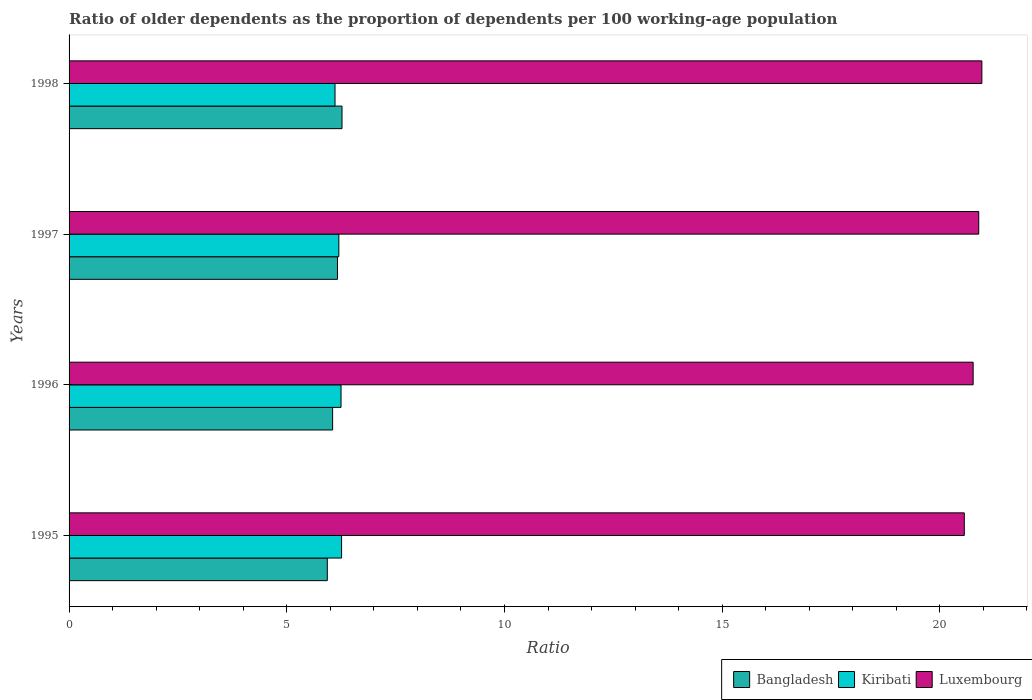Are the number of bars on each tick of the Y-axis equal?
Give a very brief answer. Yes. How many bars are there on the 4th tick from the top?
Provide a succinct answer. 3. How many bars are there on the 4th tick from the bottom?
Give a very brief answer. 3. What is the label of the 3rd group of bars from the top?
Your response must be concise. 1996. In how many cases, is the number of bars for a given year not equal to the number of legend labels?
Give a very brief answer. 0. What is the age dependency ratio(old) in Kiribati in 1996?
Provide a short and direct response. 6.25. Across all years, what is the maximum age dependency ratio(old) in Luxembourg?
Provide a succinct answer. 20.96. Across all years, what is the minimum age dependency ratio(old) in Luxembourg?
Your answer should be compact. 20.56. In which year was the age dependency ratio(old) in Luxembourg maximum?
Give a very brief answer. 1998. What is the total age dependency ratio(old) in Kiribati in the graph?
Provide a succinct answer. 24.81. What is the difference between the age dependency ratio(old) in Bangladesh in 1995 and that in 1997?
Keep it short and to the point. -0.23. What is the difference between the age dependency ratio(old) in Luxembourg in 1995 and the age dependency ratio(old) in Kiribati in 1997?
Provide a short and direct response. 14.36. What is the average age dependency ratio(old) in Kiribati per year?
Provide a short and direct response. 6.2. In the year 1998, what is the difference between the age dependency ratio(old) in Luxembourg and age dependency ratio(old) in Kiribati?
Provide a short and direct response. 14.86. In how many years, is the age dependency ratio(old) in Luxembourg greater than 13 ?
Offer a very short reply. 4. What is the ratio of the age dependency ratio(old) in Kiribati in 1995 to that in 1998?
Make the answer very short. 1.02. Is the age dependency ratio(old) in Bangladesh in 1996 less than that in 1998?
Your response must be concise. Yes. Is the difference between the age dependency ratio(old) in Luxembourg in 1995 and 1997 greater than the difference between the age dependency ratio(old) in Kiribati in 1995 and 1997?
Provide a succinct answer. No. What is the difference between the highest and the second highest age dependency ratio(old) in Kiribati?
Keep it short and to the point. 0.01. What is the difference between the highest and the lowest age dependency ratio(old) in Luxembourg?
Give a very brief answer. 0.4. In how many years, is the age dependency ratio(old) in Luxembourg greater than the average age dependency ratio(old) in Luxembourg taken over all years?
Your response must be concise. 2. Is the sum of the age dependency ratio(old) in Luxembourg in 1995 and 1997 greater than the maximum age dependency ratio(old) in Kiribati across all years?
Ensure brevity in your answer.  Yes. What does the 2nd bar from the top in 1997 represents?
Make the answer very short. Kiribati. What does the 2nd bar from the bottom in 1998 represents?
Offer a terse response. Kiribati. How many bars are there?
Make the answer very short. 12. Are all the bars in the graph horizontal?
Give a very brief answer. Yes. How many years are there in the graph?
Your answer should be compact. 4. Are the values on the major ticks of X-axis written in scientific E-notation?
Give a very brief answer. No. Where does the legend appear in the graph?
Keep it short and to the point. Bottom right. How are the legend labels stacked?
Keep it short and to the point. Horizontal. What is the title of the graph?
Give a very brief answer. Ratio of older dependents as the proportion of dependents per 100 working-age population. Does "Haiti" appear as one of the legend labels in the graph?
Provide a succinct answer. No. What is the label or title of the X-axis?
Give a very brief answer. Ratio. What is the Ratio in Bangladesh in 1995?
Keep it short and to the point. 5.93. What is the Ratio in Kiribati in 1995?
Ensure brevity in your answer.  6.26. What is the Ratio of Luxembourg in 1995?
Provide a succinct answer. 20.56. What is the Ratio of Bangladesh in 1996?
Provide a succinct answer. 6.05. What is the Ratio of Kiribati in 1996?
Make the answer very short. 6.25. What is the Ratio in Luxembourg in 1996?
Provide a short and direct response. 20.76. What is the Ratio of Bangladesh in 1997?
Your answer should be compact. 6.16. What is the Ratio of Kiribati in 1997?
Your answer should be very brief. 6.2. What is the Ratio of Luxembourg in 1997?
Provide a short and direct response. 20.89. What is the Ratio of Bangladesh in 1998?
Your answer should be compact. 6.27. What is the Ratio of Kiribati in 1998?
Your response must be concise. 6.11. What is the Ratio in Luxembourg in 1998?
Give a very brief answer. 20.96. Across all years, what is the maximum Ratio of Bangladesh?
Provide a succinct answer. 6.27. Across all years, what is the maximum Ratio in Kiribati?
Your answer should be compact. 6.26. Across all years, what is the maximum Ratio of Luxembourg?
Ensure brevity in your answer.  20.96. Across all years, what is the minimum Ratio of Bangladesh?
Give a very brief answer. 5.93. Across all years, what is the minimum Ratio in Kiribati?
Provide a succinct answer. 6.11. Across all years, what is the minimum Ratio of Luxembourg?
Keep it short and to the point. 20.56. What is the total Ratio in Bangladesh in the graph?
Your answer should be very brief. 24.42. What is the total Ratio in Kiribati in the graph?
Provide a succinct answer. 24.81. What is the total Ratio in Luxembourg in the graph?
Your answer should be very brief. 83.18. What is the difference between the Ratio in Bangladesh in 1995 and that in 1996?
Provide a short and direct response. -0.12. What is the difference between the Ratio in Kiribati in 1995 and that in 1996?
Provide a short and direct response. 0.01. What is the difference between the Ratio of Luxembourg in 1995 and that in 1996?
Make the answer very short. -0.2. What is the difference between the Ratio in Bangladesh in 1995 and that in 1997?
Provide a succinct answer. -0.23. What is the difference between the Ratio of Kiribati in 1995 and that in 1997?
Provide a short and direct response. 0.06. What is the difference between the Ratio in Luxembourg in 1995 and that in 1997?
Offer a very short reply. -0.33. What is the difference between the Ratio in Bangladesh in 1995 and that in 1998?
Your response must be concise. -0.34. What is the difference between the Ratio in Kiribati in 1995 and that in 1998?
Give a very brief answer. 0.15. What is the difference between the Ratio in Luxembourg in 1995 and that in 1998?
Give a very brief answer. -0.4. What is the difference between the Ratio in Bangladesh in 1996 and that in 1997?
Provide a short and direct response. -0.11. What is the difference between the Ratio in Kiribati in 1996 and that in 1997?
Ensure brevity in your answer.  0.05. What is the difference between the Ratio of Luxembourg in 1996 and that in 1997?
Your answer should be very brief. -0.13. What is the difference between the Ratio in Bangladesh in 1996 and that in 1998?
Ensure brevity in your answer.  -0.22. What is the difference between the Ratio of Kiribati in 1996 and that in 1998?
Offer a terse response. 0.14. What is the difference between the Ratio in Bangladesh in 1997 and that in 1998?
Offer a terse response. -0.1. What is the difference between the Ratio in Kiribati in 1997 and that in 1998?
Offer a terse response. 0.09. What is the difference between the Ratio in Luxembourg in 1997 and that in 1998?
Provide a short and direct response. -0.07. What is the difference between the Ratio of Bangladesh in 1995 and the Ratio of Kiribati in 1996?
Offer a terse response. -0.32. What is the difference between the Ratio of Bangladesh in 1995 and the Ratio of Luxembourg in 1996?
Make the answer very short. -14.83. What is the difference between the Ratio in Kiribati in 1995 and the Ratio in Luxembourg in 1996?
Offer a very short reply. -14.51. What is the difference between the Ratio in Bangladesh in 1995 and the Ratio in Kiribati in 1997?
Your answer should be compact. -0.27. What is the difference between the Ratio of Bangladesh in 1995 and the Ratio of Luxembourg in 1997?
Your response must be concise. -14.96. What is the difference between the Ratio of Kiribati in 1995 and the Ratio of Luxembourg in 1997?
Your answer should be compact. -14.63. What is the difference between the Ratio in Bangladesh in 1995 and the Ratio in Kiribati in 1998?
Your answer should be compact. -0.18. What is the difference between the Ratio in Bangladesh in 1995 and the Ratio in Luxembourg in 1998?
Ensure brevity in your answer.  -15.03. What is the difference between the Ratio in Kiribati in 1995 and the Ratio in Luxembourg in 1998?
Your answer should be compact. -14.71. What is the difference between the Ratio of Bangladesh in 1996 and the Ratio of Kiribati in 1997?
Your response must be concise. -0.14. What is the difference between the Ratio in Bangladesh in 1996 and the Ratio in Luxembourg in 1997?
Your response must be concise. -14.84. What is the difference between the Ratio of Kiribati in 1996 and the Ratio of Luxembourg in 1997?
Make the answer very short. -14.65. What is the difference between the Ratio in Bangladesh in 1996 and the Ratio in Kiribati in 1998?
Offer a terse response. -0.05. What is the difference between the Ratio of Bangladesh in 1996 and the Ratio of Luxembourg in 1998?
Your response must be concise. -14.91. What is the difference between the Ratio in Kiribati in 1996 and the Ratio in Luxembourg in 1998?
Provide a succinct answer. -14.72. What is the difference between the Ratio in Bangladesh in 1997 and the Ratio in Kiribati in 1998?
Provide a short and direct response. 0.06. What is the difference between the Ratio in Bangladesh in 1997 and the Ratio in Luxembourg in 1998?
Offer a terse response. -14.8. What is the difference between the Ratio of Kiribati in 1997 and the Ratio of Luxembourg in 1998?
Your answer should be compact. -14.77. What is the average Ratio of Bangladesh per year?
Give a very brief answer. 6.1. What is the average Ratio in Kiribati per year?
Your answer should be compact. 6.2. What is the average Ratio in Luxembourg per year?
Make the answer very short. 20.8. In the year 1995, what is the difference between the Ratio of Bangladesh and Ratio of Kiribati?
Keep it short and to the point. -0.33. In the year 1995, what is the difference between the Ratio in Bangladesh and Ratio in Luxembourg?
Make the answer very short. -14.63. In the year 1995, what is the difference between the Ratio in Kiribati and Ratio in Luxembourg?
Ensure brevity in your answer.  -14.3. In the year 1996, what is the difference between the Ratio of Bangladesh and Ratio of Kiribati?
Your answer should be very brief. -0.19. In the year 1996, what is the difference between the Ratio in Bangladesh and Ratio in Luxembourg?
Provide a succinct answer. -14.71. In the year 1996, what is the difference between the Ratio in Kiribati and Ratio in Luxembourg?
Your response must be concise. -14.52. In the year 1997, what is the difference between the Ratio in Bangladesh and Ratio in Kiribati?
Offer a very short reply. -0.03. In the year 1997, what is the difference between the Ratio of Bangladesh and Ratio of Luxembourg?
Give a very brief answer. -14.73. In the year 1997, what is the difference between the Ratio in Kiribati and Ratio in Luxembourg?
Ensure brevity in your answer.  -14.7. In the year 1998, what is the difference between the Ratio in Bangladesh and Ratio in Kiribati?
Your answer should be very brief. 0.16. In the year 1998, what is the difference between the Ratio of Bangladesh and Ratio of Luxembourg?
Make the answer very short. -14.7. In the year 1998, what is the difference between the Ratio in Kiribati and Ratio in Luxembourg?
Your response must be concise. -14.86. What is the ratio of the Ratio in Bangladesh in 1995 to that in 1996?
Your answer should be very brief. 0.98. What is the ratio of the Ratio in Luxembourg in 1995 to that in 1996?
Make the answer very short. 0.99. What is the ratio of the Ratio of Bangladesh in 1995 to that in 1997?
Your answer should be compact. 0.96. What is the ratio of the Ratio in Kiribati in 1995 to that in 1997?
Give a very brief answer. 1.01. What is the ratio of the Ratio in Luxembourg in 1995 to that in 1997?
Make the answer very short. 0.98. What is the ratio of the Ratio in Bangladesh in 1995 to that in 1998?
Your answer should be very brief. 0.95. What is the ratio of the Ratio in Kiribati in 1995 to that in 1998?
Your response must be concise. 1.02. What is the ratio of the Ratio in Luxembourg in 1995 to that in 1998?
Offer a very short reply. 0.98. What is the ratio of the Ratio in Bangladesh in 1996 to that in 1997?
Your response must be concise. 0.98. What is the ratio of the Ratio in Kiribati in 1996 to that in 1997?
Offer a very short reply. 1.01. What is the ratio of the Ratio in Bangladesh in 1996 to that in 1998?
Give a very brief answer. 0.97. What is the ratio of the Ratio of Kiribati in 1996 to that in 1998?
Your answer should be very brief. 1.02. What is the ratio of the Ratio in Bangladesh in 1997 to that in 1998?
Ensure brevity in your answer.  0.98. What is the ratio of the Ratio in Kiribati in 1997 to that in 1998?
Provide a succinct answer. 1.01. What is the difference between the highest and the second highest Ratio of Bangladesh?
Your answer should be compact. 0.1. What is the difference between the highest and the second highest Ratio of Kiribati?
Give a very brief answer. 0.01. What is the difference between the highest and the second highest Ratio of Luxembourg?
Offer a terse response. 0.07. What is the difference between the highest and the lowest Ratio of Bangladesh?
Keep it short and to the point. 0.34. What is the difference between the highest and the lowest Ratio in Kiribati?
Give a very brief answer. 0.15. What is the difference between the highest and the lowest Ratio in Luxembourg?
Offer a very short reply. 0.4. 